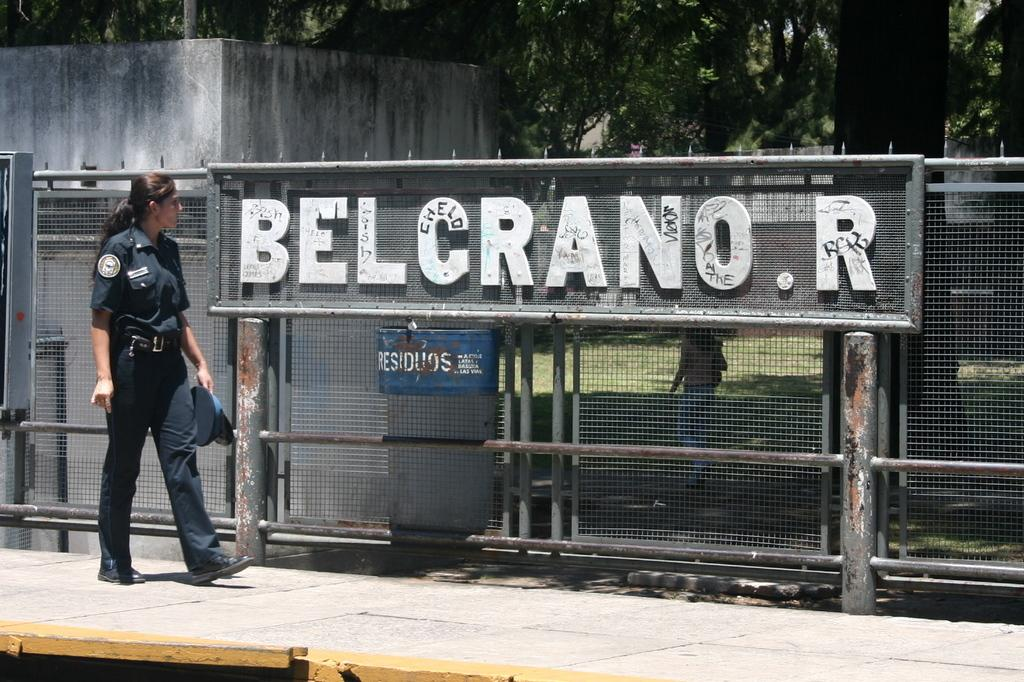What is the person in the image wearing? The person is wearing a uniform in the image. What object is the person holding? The person is holding a cap in the image. What type of barrier can be seen in the image? There is a fencing visible in the image. What type of vegetation is present in the image? There are trees in the image. What type of structure is visible in the image? There is a wall in the image. What type of straw is being used to build the wall in the image? There is no straw visible in the image, and the wall does not appear to be made of straw. 